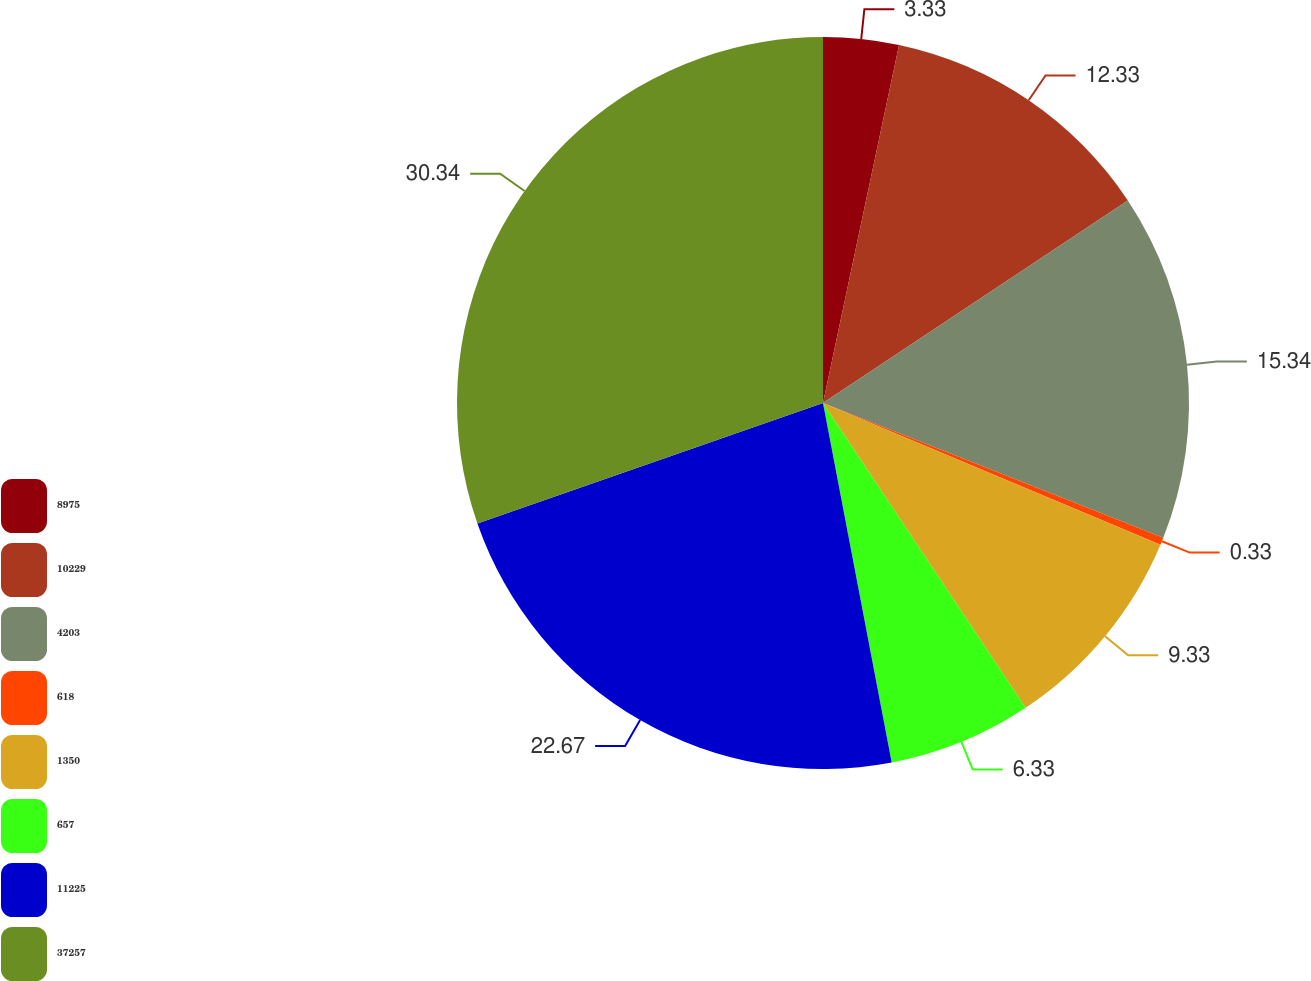<chart> <loc_0><loc_0><loc_500><loc_500><pie_chart><fcel>8975<fcel>10229<fcel>4203<fcel>618<fcel>1350<fcel>657<fcel>11225<fcel>37257<nl><fcel>3.33%<fcel>12.33%<fcel>15.33%<fcel>0.33%<fcel>9.33%<fcel>6.33%<fcel>22.66%<fcel>30.33%<nl></chart> 